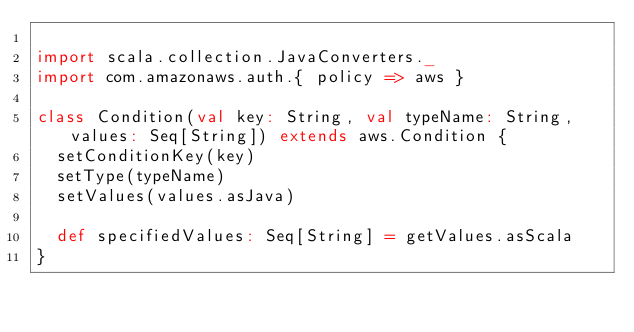Convert code to text. <code><loc_0><loc_0><loc_500><loc_500><_Scala_>
import scala.collection.JavaConverters._
import com.amazonaws.auth.{ policy => aws }

class Condition(val key: String, val typeName: String, values: Seq[String]) extends aws.Condition {
  setConditionKey(key)
  setType(typeName)
  setValues(values.asJava)

  def specifiedValues: Seq[String] = getValues.asScala
}
</code> 